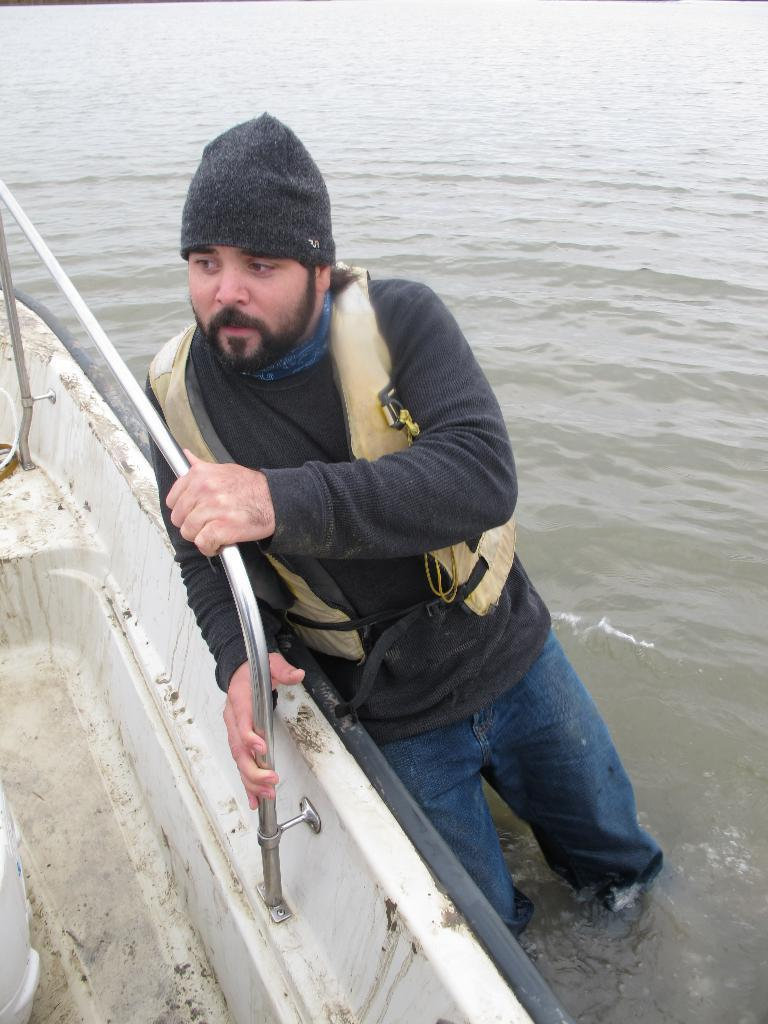Who is present in the image? There is a man in the image. What is the man wearing on his head? The man is wearing a cap. What type of pants is the man wearing? The man is wearing blue jeans. What is the man holding in the image? The man is holding the stand of a boat. What can be seen in the background of the image? The background of the image is full of water. What type of joke is the man telling in the image? There is no indication in the image that the man is telling a joke, so it cannot be determined from the picture. 